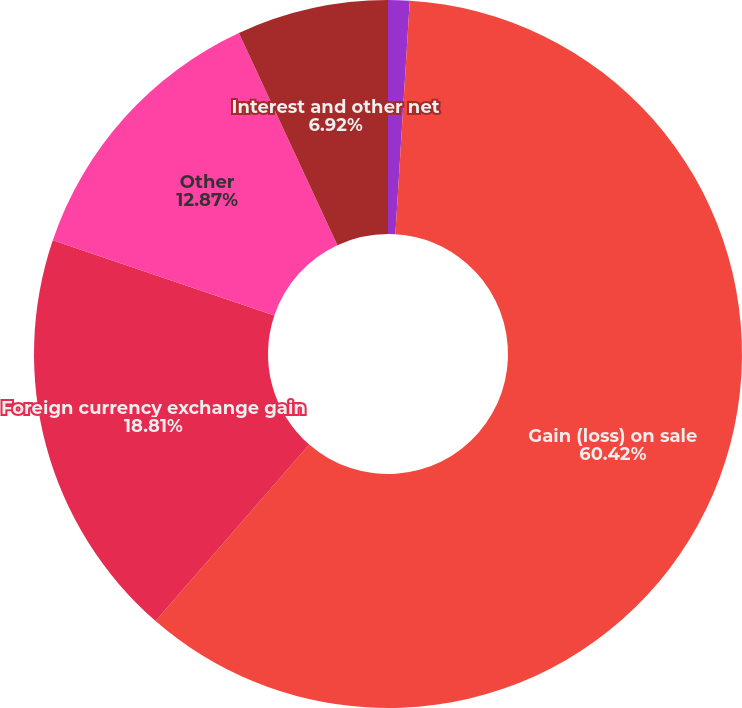Convert chart. <chart><loc_0><loc_0><loc_500><loc_500><pie_chart><fcel>Interest income (expense) net<fcel>Gain (loss) on sale<fcel>Foreign currency exchange gain<fcel>Other<fcel>Interest and other net<nl><fcel>0.98%<fcel>60.42%<fcel>18.81%<fcel>12.87%<fcel>6.92%<nl></chart> 